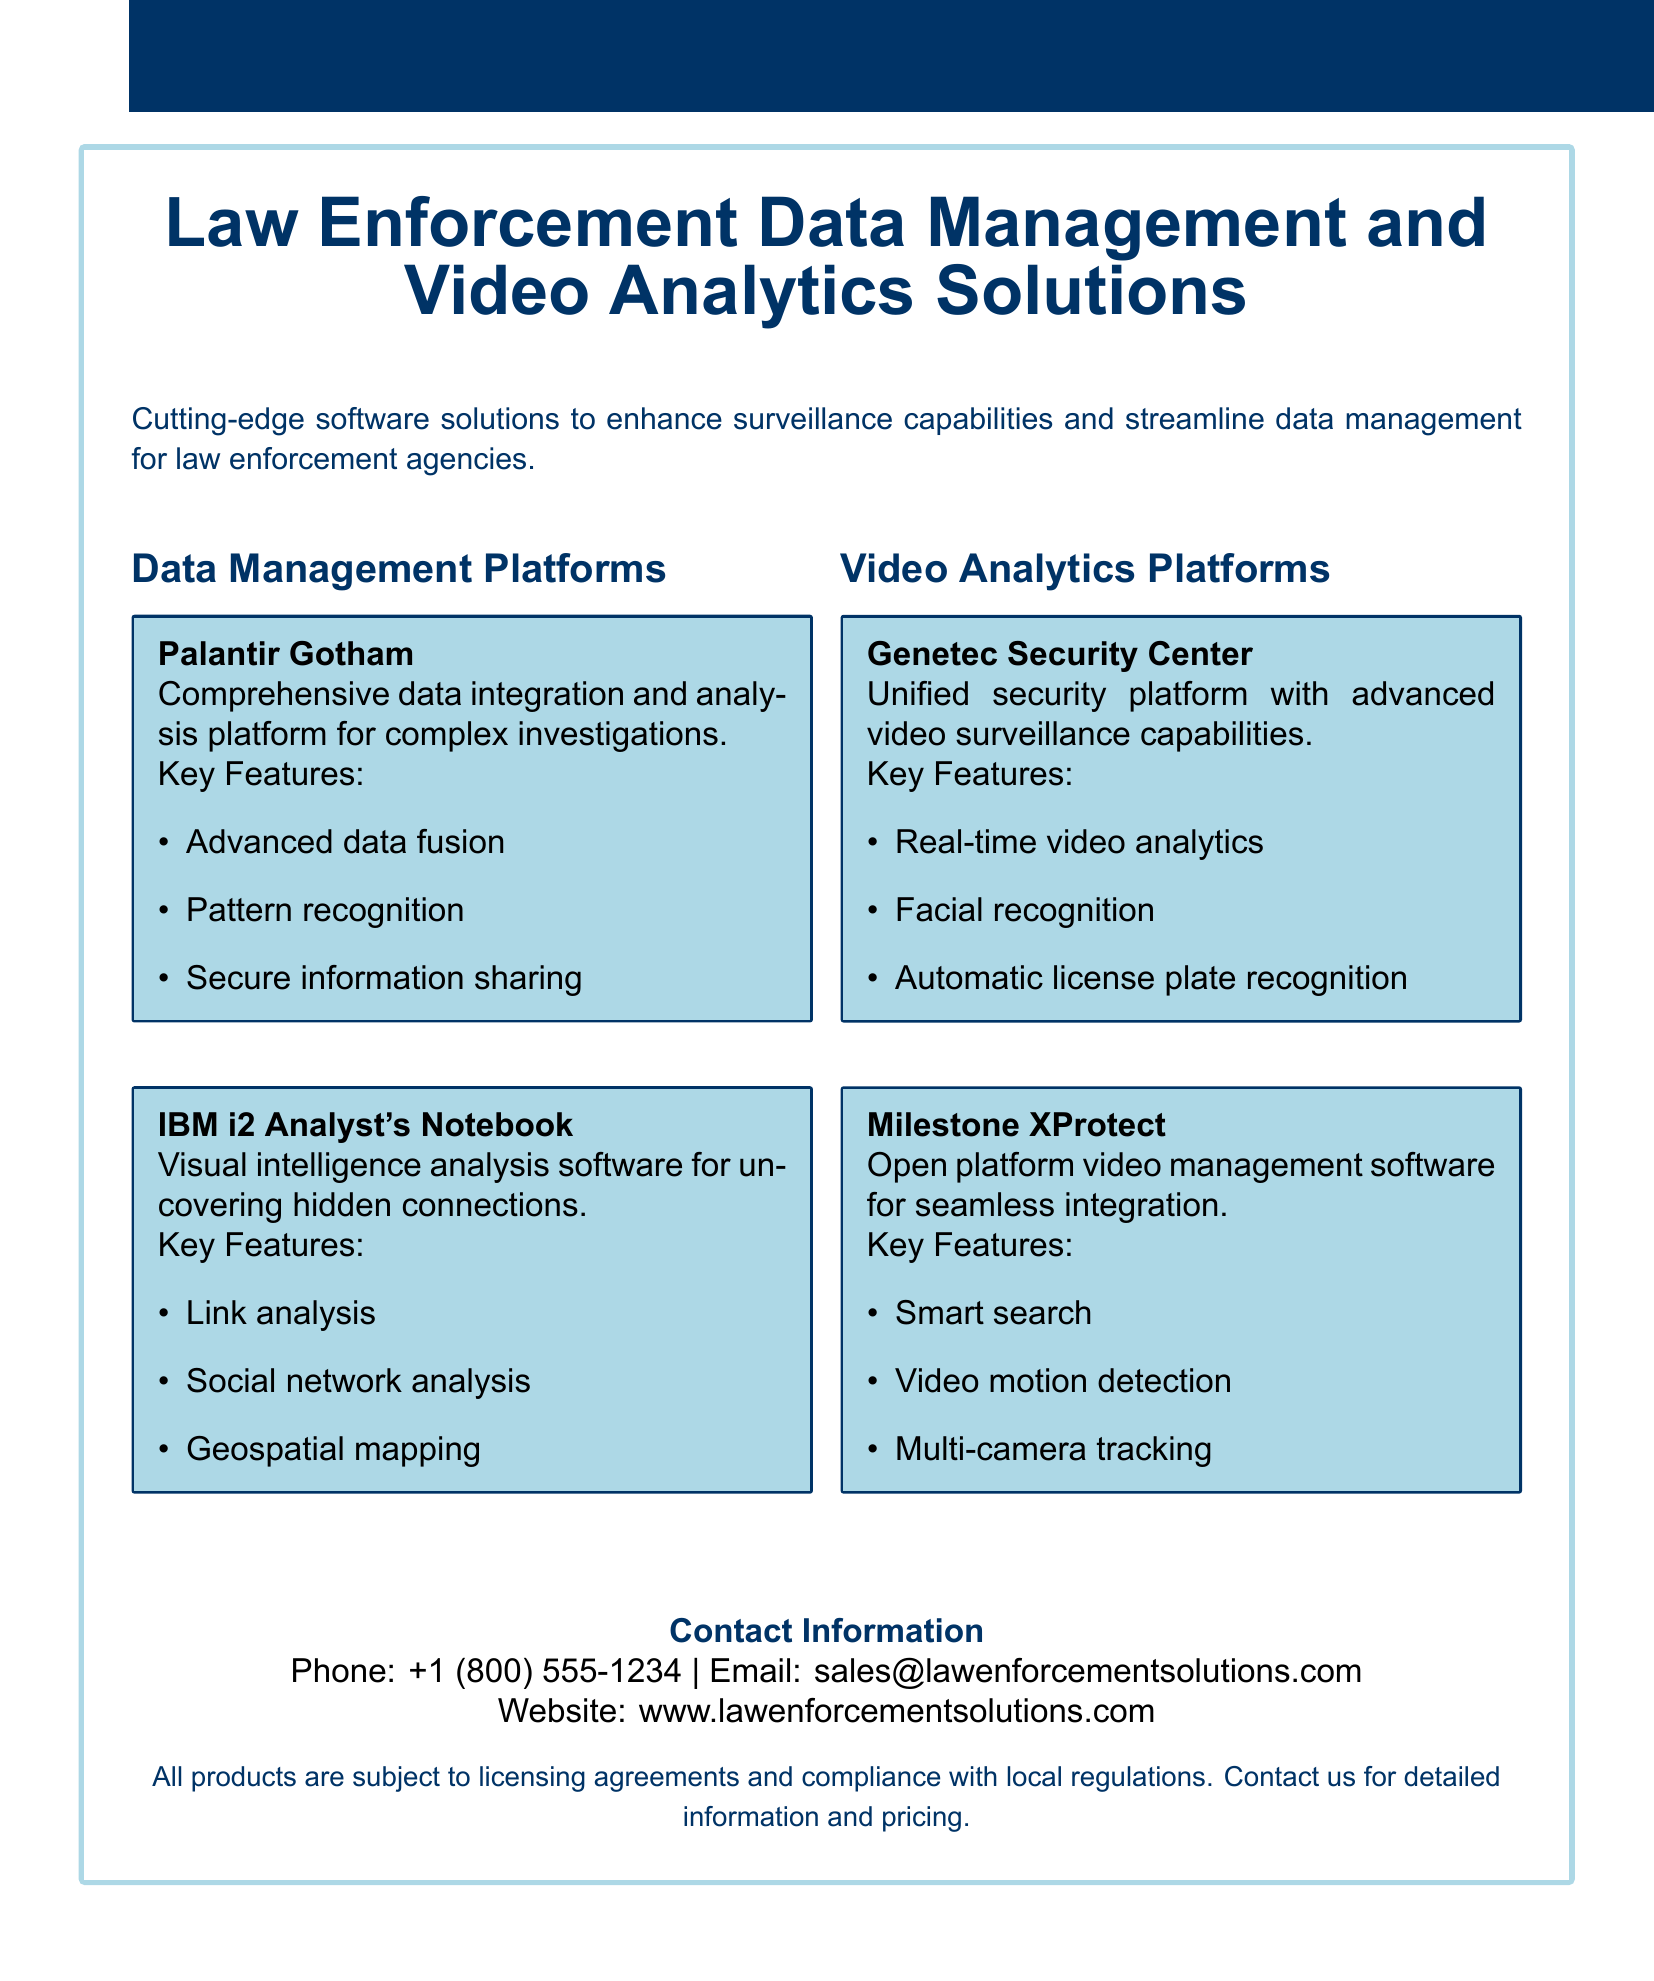What is the name of the comprehensive data integration platform? The document lists Palantir Gotham as the comprehensive data integration and analysis platform.
Answer: Palantir Gotham How many video analytics platforms are mentioned? The document features two video analytics platforms: Genetec Security Center and Milestone XProtect.
Answer: 2 What feature is included in IBM i2 Analyst's Notebook? IBM i2 Analyst's Notebook includes link analysis as a key feature for uncovering hidden connections.
Answer: Link analysis What is the contact email provided in the document? The document states the contact email as sales@lawenforcementsolutions.com for inquiries.
Answer: sales@lawenforcementsolutions.com What is a key feature of Genetec Security Center? Genetec Security Center offers real-time video analytics as one of its key features.
Answer: Real-time video analytics Which video management software is described as an open platform? The document describes Milestone XProtect as the open platform video management software.
Answer: Milestone XProtect What type of analysis does Palantir Gotham facilitate? Palantir Gotham facilitates complex investigations through advanced data fusion and pattern recognition.
Answer: Complex investigations What is the phone number for contact information? The phone number provided for contact in the document is +1 (800) 555-1234.
Answer: +1 (800) 555-1234 What type of mapping is included in IBM i2 Analyst's Notebook? The document mentions geospatial mapping as a feature included in IBM i2 Analyst's Notebook.
Answer: Geospatial mapping 